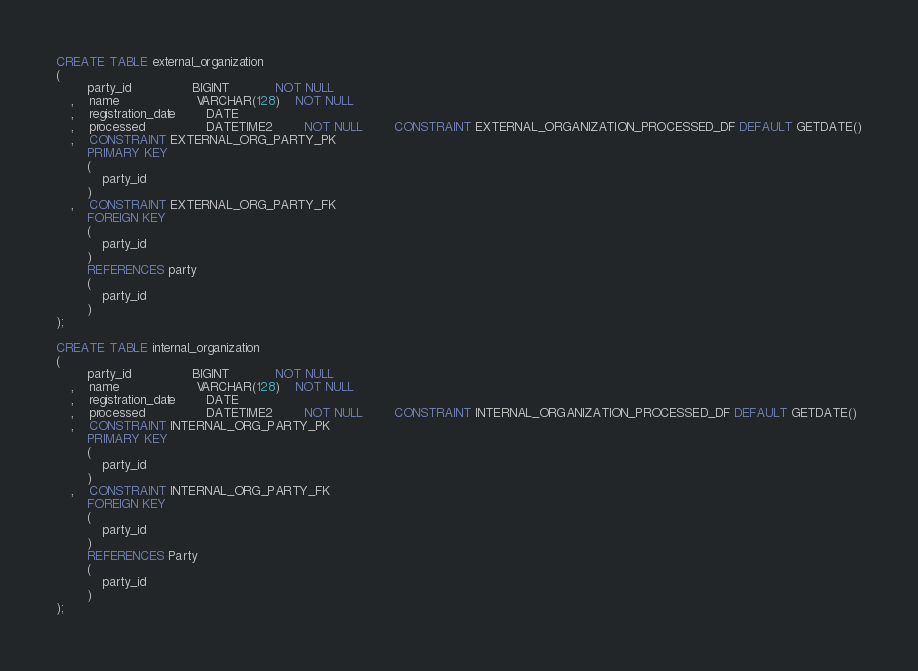Convert code to text. <code><loc_0><loc_0><loc_500><loc_500><_SQL_>CREATE TABLE external_organization
(
		party_id				BIGINT			NOT NULL
	,	name					VARCHAR(128)	NOT NULL
	,	registration_date		DATE
	,	processed				DATETIME2		NOT NULL 		CONSTRAINT EXTERNAL_ORGANIZATION_PROCESSED_DF DEFAULT GETDATE()
	,	CONSTRAINT EXTERNAL_ORG_PARTY_PK
		PRIMARY KEY
		(
			party_id
		)
	,	CONSTRAINT EXTERNAL_ORG_PARTY_FK
		FOREIGN KEY
		(
			party_id
		)
		REFERENCES party
		(
			party_id
		)
);

CREATE TABLE internal_organization
(
		party_id				BIGINT			NOT NULL
	,	name					VARCHAR(128)	NOT NULL
	,	registration_date		DATE
	,	processed				DATETIME2		NOT NULL 		CONSTRAINT INTERNAL_ORGANIZATION_PROCESSED_DF DEFAULT GETDATE()
	,	CONSTRAINT INTERNAL_ORG_PARTY_PK
		PRIMARY KEY
		(
			party_id
		)
	,	CONSTRAINT INTERNAL_ORG_PARTY_FK
		FOREIGN KEY
		(
			party_id
		)
		REFERENCES Party
		(
			party_id
		)
);</code> 